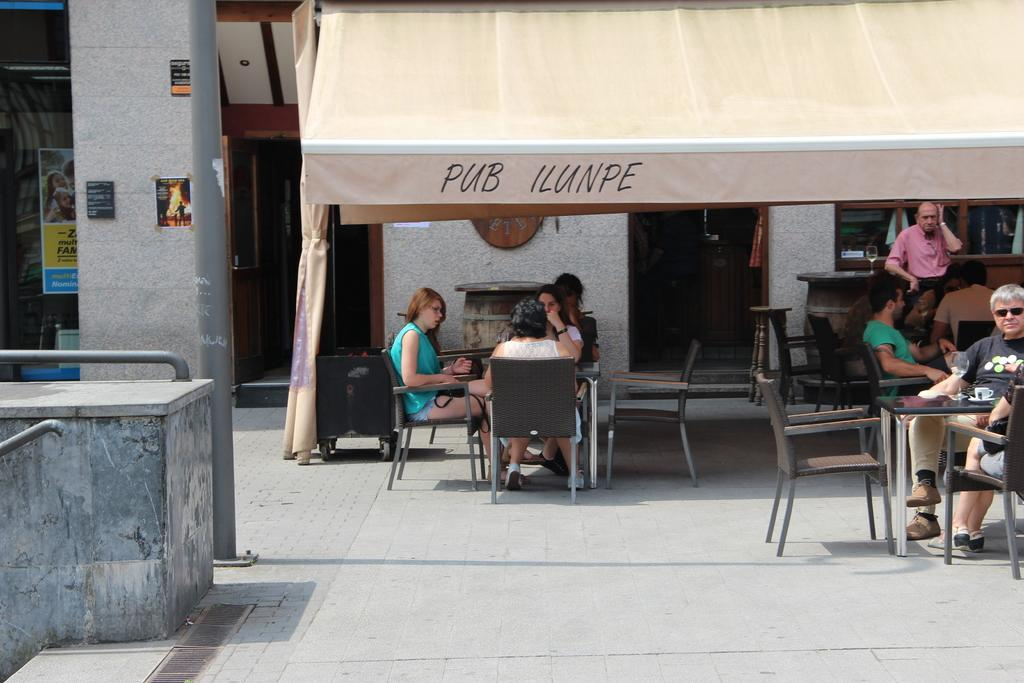How many women are in the image? There are three women in the image. What are the women doing in the image? The women are sitting on chairs and having a conversation. Where are the women located in the image? The women are inside a tent. Is there anyone else in the image besides the women? Yes, there is a man sitting on a chair on the right side of the image. Can you describe the person visible in the top right corner of the image? There is a person visible in the top right corner of the image, but their features are not clear enough to provide a detailed description. What sound does the tiger make in the image? There is no tiger present in the image, so it is not possible to determine the sound it might make. What type of picture is hanging on the wall in the image? There is no mention of a picture hanging on the wall in the image, so it cannot be determined from the provided facts. 